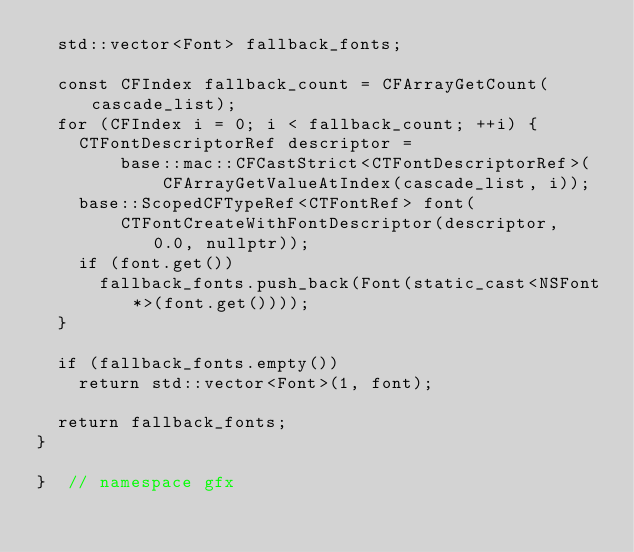<code> <loc_0><loc_0><loc_500><loc_500><_ObjectiveC_>  std::vector<Font> fallback_fonts;

  const CFIndex fallback_count = CFArrayGetCount(cascade_list);
  for (CFIndex i = 0; i < fallback_count; ++i) {
    CTFontDescriptorRef descriptor =
        base::mac::CFCastStrict<CTFontDescriptorRef>(
            CFArrayGetValueAtIndex(cascade_list, i));
    base::ScopedCFTypeRef<CTFontRef> font(
        CTFontCreateWithFontDescriptor(descriptor, 0.0, nullptr));
    if (font.get())
      fallback_fonts.push_back(Font(static_cast<NSFont*>(font.get())));
  }

  if (fallback_fonts.empty())
    return std::vector<Font>(1, font);

  return fallback_fonts;
}

}  // namespace gfx
</code> 